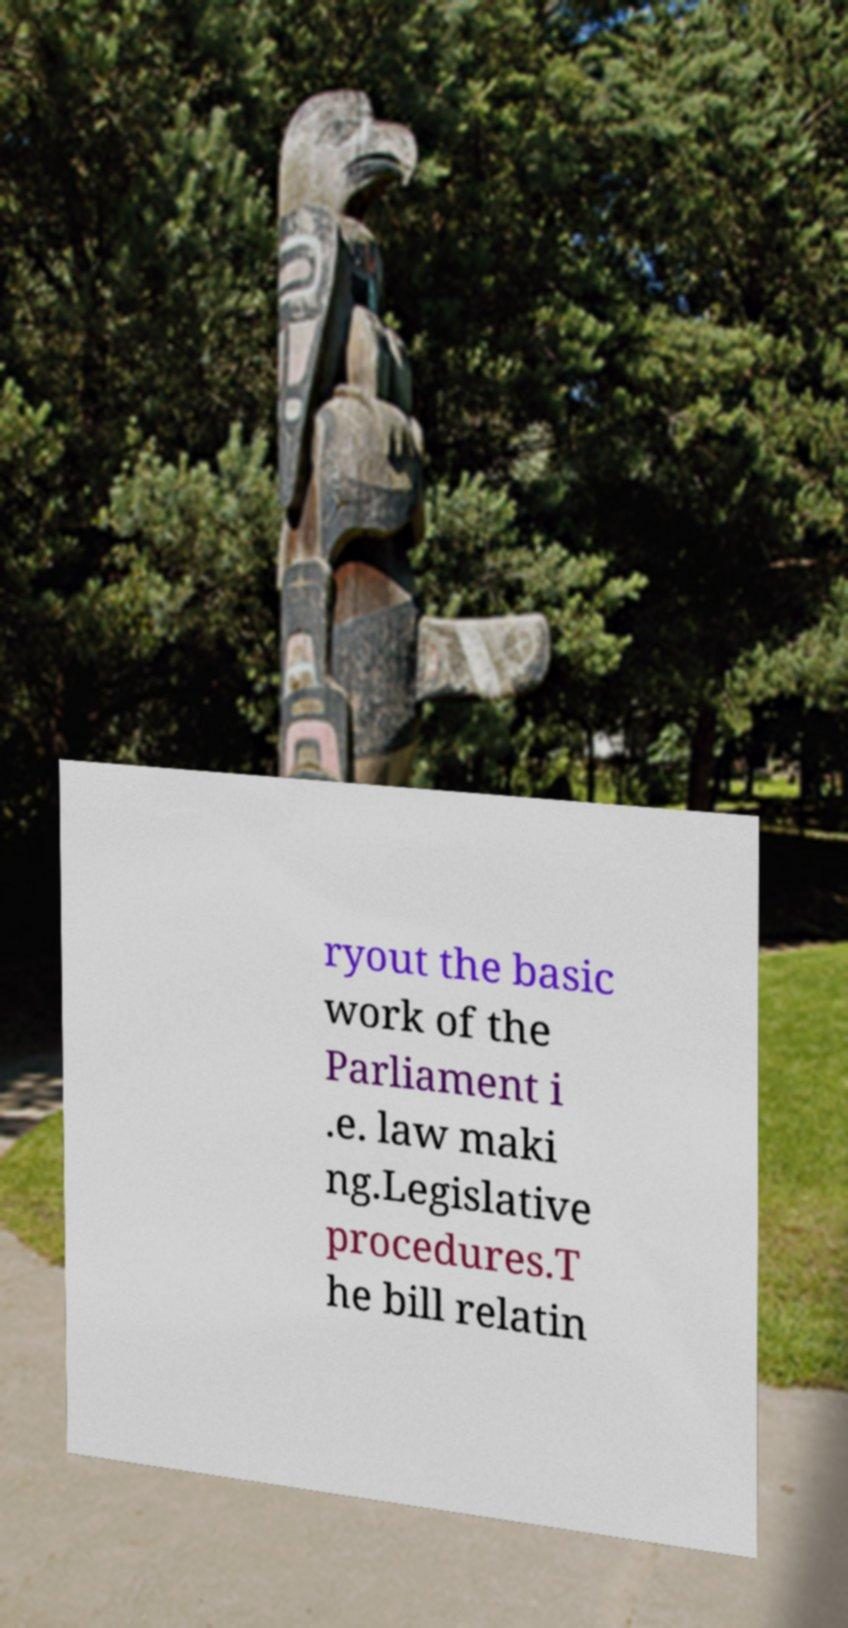Can you read and provide the text displayed in the image?This photo seems to have some interesting text. Can you extract and type it out for me? ryout the basic work of the Parliament i .e. law maki ng.Legislative procedures.T he bill relatin 